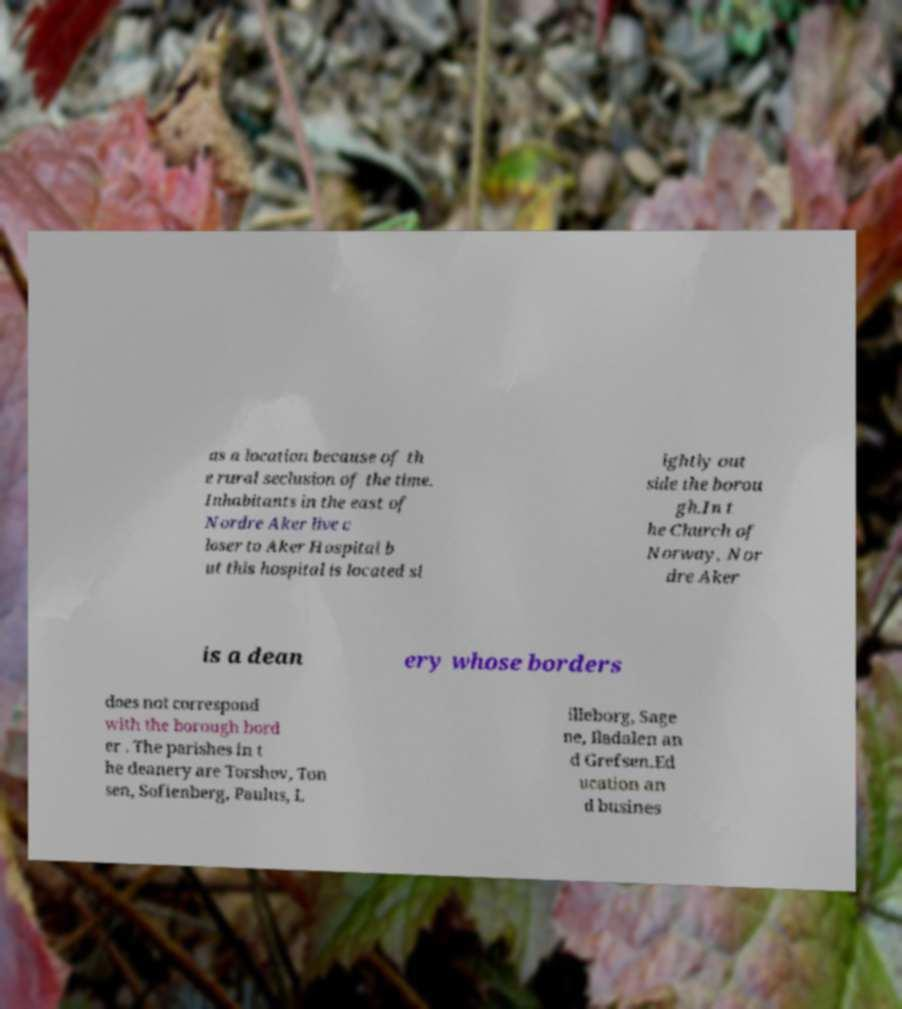Please read and relay the text visible in this image. What does it say? as a location because of th e rural seclusion of the time. Inhabitants in the east of Nordre Aker live c loser to Aker Hospital b ut this hospital is located sl ightly out side the borou gh.In t he Church of Norway, Nor dre Aker is a dean ery whose borders does not correspond with the borough bord er . The parishes in t he deanery are Torshov, Ton sen, Sofienberg, Paulus, L illeborg, Sage ne, Iladalen an d Grefsen.Ed ucation an d busines 